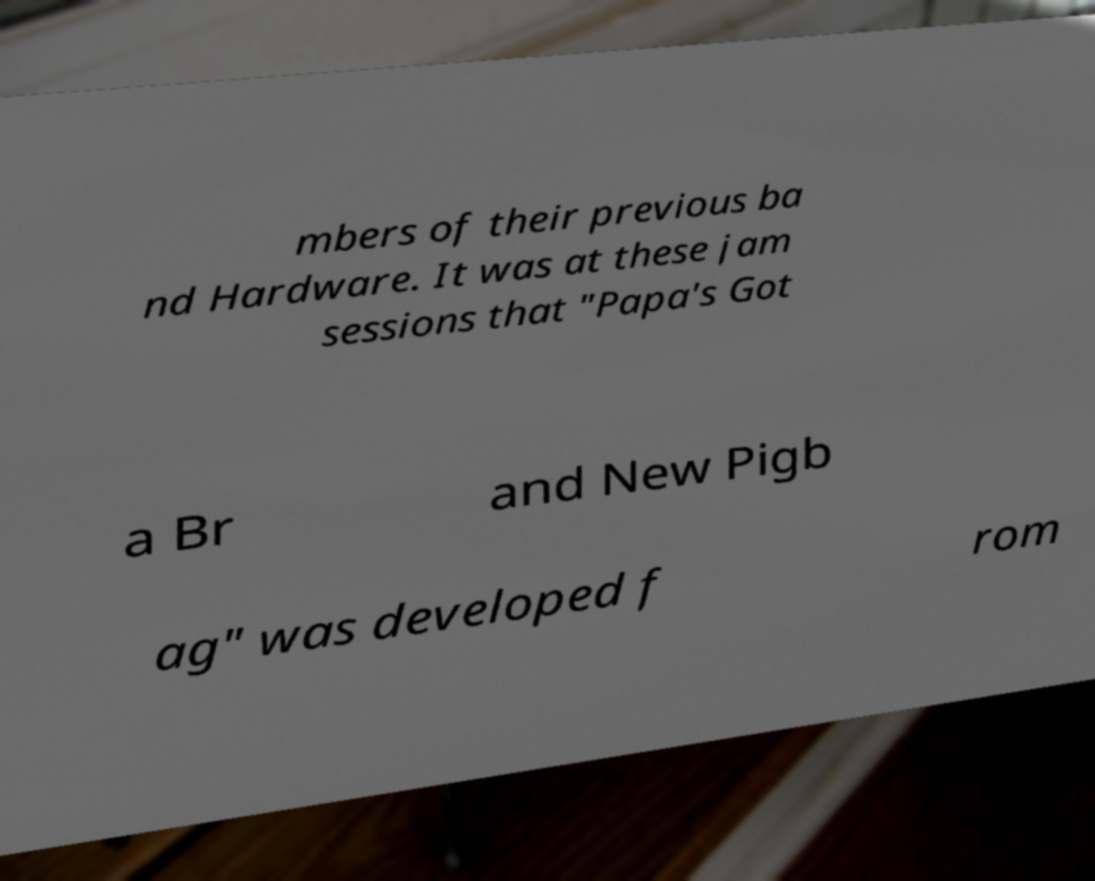Could you extract and type out the text from this image? mbers of their previous ba nd Hardware. It was at these jam sessions that "Papa's Got a Br and New Pigb ag" was developed f rom 